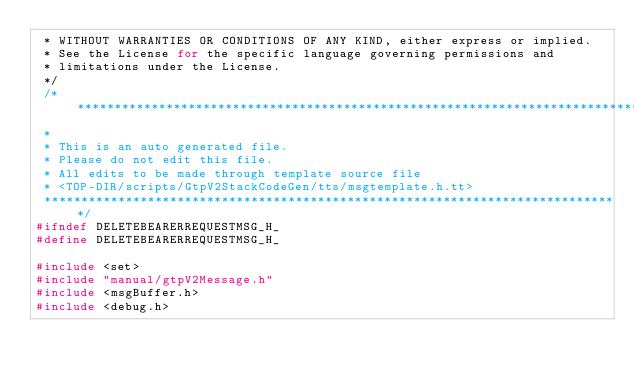Convert code to text. <code><loc_0><loc_0><loc_500><loc_500><_C_> * WITHOUT WARRANTIES OR CONDITIONS OF ANY KIND, either express or implied.
 * See the License for the specific language governing permissions and
 * limitations under the License.
 */
 /******************************************************************************
 *
 * This is an auto generated file.
 * Please do not edit this file.
 * All edits to be made through template source file
 * <TOP-DIR/scripts/GtpV2StackCodeGen/tts/msgtemplate.h.tt>
 ******************************************************************************/
#ifndef DELETEBEARERREQUESTMSG_H_
#define DELETEBEARERREQUESTMSG_H_

#include <set>
#include "manual/gtpV2Message.h"
#include <msgBuffer.h>
#include <debug.h></code> 